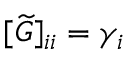Convert formula to latex. <formula><loc_0><loc_0><loc_500><loc_500>[ \widetilde { G } ] _ { i i } = \gamma _ { i }</formula> 